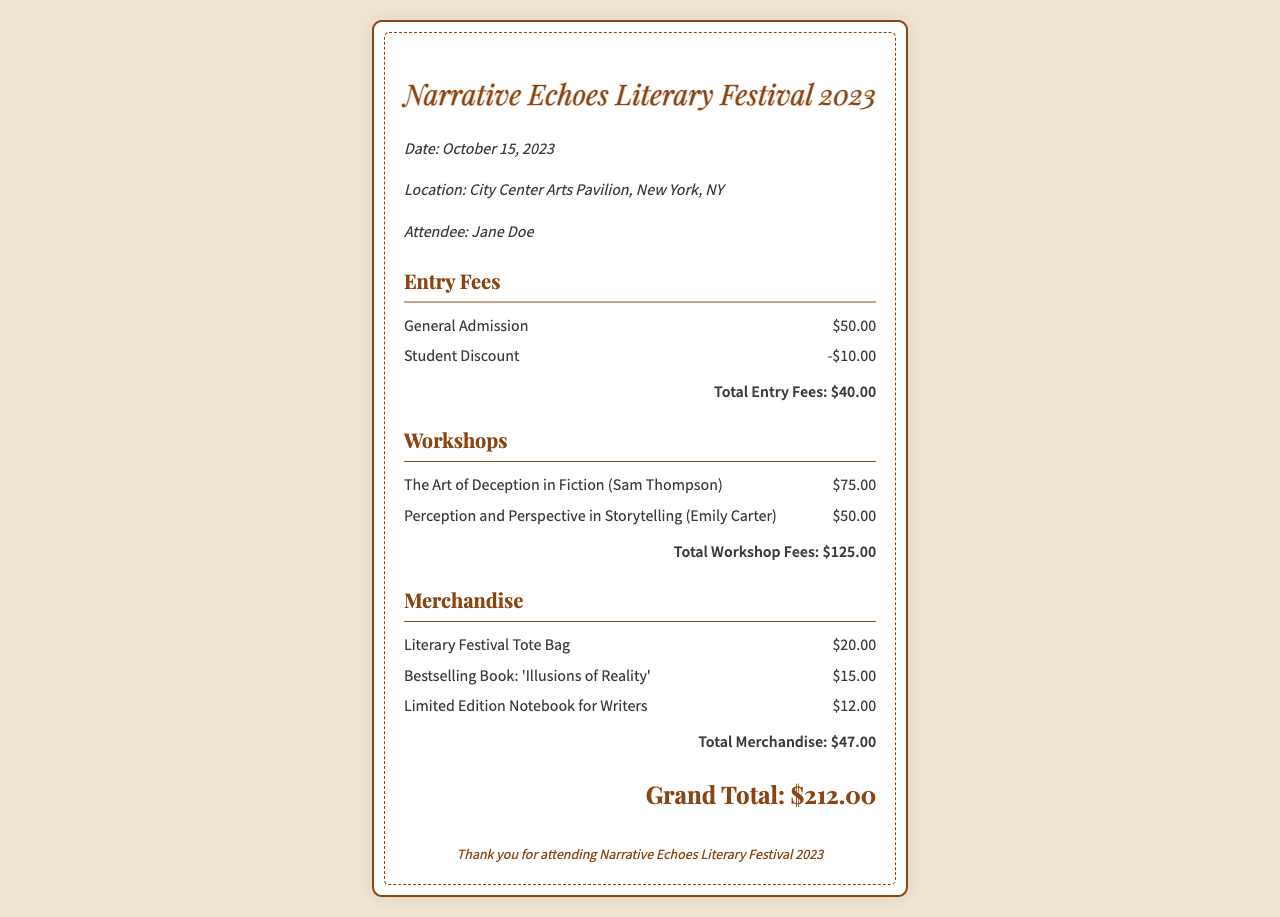What is the date of the festival? The date of the festival is explicitly stated in the document.
Answer: October 15, 2023 What is the total entry fee after discount? The total entry fees section summarizes the entry fee calculations, including a student discount.
Answer: $40.00 Who conducted the workshop on deception in fiction? The workshops section lists the names of the workshop leaders for reference.
Answer: Sam Thompson What is the price of the Literary Festival Tote Bag? The merchandise section includes the prices of various items, including the tote bag.
Answer: $20.00 What is the grand total amount charged? The document provides a grand total that consolidates all fees and merchandise costs.
Answer: $212.00 How much was spent on workshops? The total workshop fees summarize the costs associated with attending specific workshops.
Answer: $125.00 Which book was identified as a bestselling item? The merchandise section lists various items, including a bestselling book title.
Answer: 'Illusions of Reality' What is one theme covered in the workshops? The workshops describe themes related to storytelling, specifically about perception and deception.
Answer: Deception What is the location of the festival? The document explicitly states the venue for the festival activities.
Answer: City Center Arts Pavilion, New York, NY 